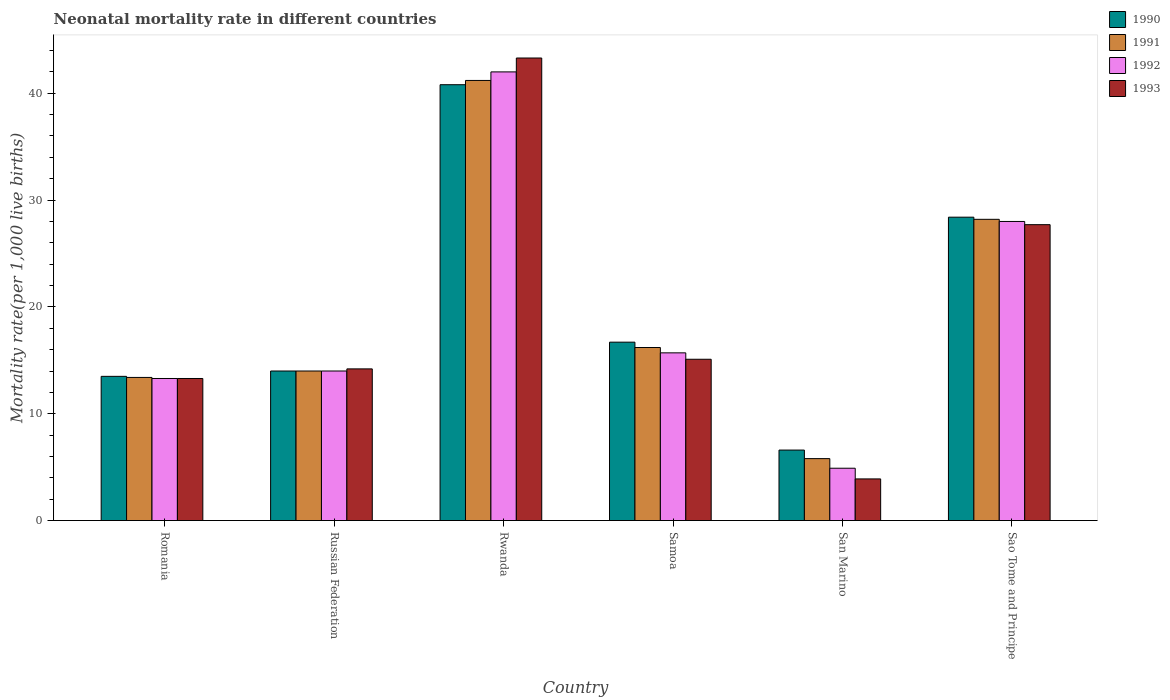Are the number of bars per tick equal to the number of legend labels?
Ensure brevity in your answer.  Yes. Are the number of bars on each tick of the X-axis equal?
Your answer should be compact. Yes. How many bars are there on the 1st tick from the right?
Offer a very short reply. 4. What is the label of the 1st group of bars from the left?
Provide a succinct answer. Romania. In which country was the neonatal mortality rate in 1991 maximum?
Your response must be concise. Rwanda. In which country was the neonatal mortality rate in 1990 minimum?
Your answer should be very brief. San Marino. What is the total neonatal mortality rate in 1990 in the graph?
Provide a short and direct response. 120. What is the difference between the neonatal mortality rate in 1992 in Romania and the neonatal mortality rate in 1990 in Russian Federation?
Provide a short and direct response. -0.7. What is the average neonatal mortality rate in 1993 per country?
Provide a short and direct response. 19.58. What is the difference between the neonatal mortality rate of/in 1993 and neonatal mortality rate of/in 1991 in Sao Tome and Principe?
Your answer should be very brief. -0.5. What is the ratio of the neonatal mortality rate in 1992 in Romania to that in Russian Federation?
Keep it short and to the point. 0.95. What is the difference between the highest and the second highest neonatal mortality rate in 1990?
Your answer should be very brief. 24.1. What is the difference between the highest and the lowest neonatal mortality rate in 1992?
Ensure brevity in your answer.  37.1. In how many countries, is the neonatal mortality rate in 1991 greater than the average neonatal mortality rate in 1991 taken over all countries?
Your response must be concise. 2. Is it the case that in every country, the sum of the neonatal mortality rate in 1990 and neonatal mortality rate in 1993 is greater than the sum of neonatal mortality rate in 1992 and neonatal mortality rate in 1991?
Provide a succinct answer. No. Is it the case that in every country, the sum of the neonatal mortality rate in 1991 and neonatal mortality rate in 1993 is greater than the neonatal mortality rate in 1990?
Provide a succinct answer. Yes. How many bars are there?
Your response must be concise. 24. How many countries are there in the graph?
Make the answer very short. 6. Are the values on the major ticks of Y-axis written in scientific E-notation?
Your answer should be very brief. No. Does the graph contain any zero values?
Your answer should be compact. No. Where does the legend appear in the graph?
Provide a succinct answer. Top right. How many legend labels are there?
Provide a short and direct response. 4. How are the legend labels stacked?
Your response must be concise. Vertical. What is the title of the graph?
Make the answer very short. Neonatal mortality rate in different countries. What is the label or title of the Y-axis?
Offer a terse response. Mortality rate(per 1,0 live births). What is the Mortality rate(per 1,000 live births) of 1990 in Romania?
Your answer should be very brief. 13.5. What is the Mortality rate(per 1,000 live births) in 1991 in Romania?
Offer a terse response. 13.4. What is the Mortality rate(per 1,000 live births) of 1992 in Romania?
Give a very brief answer. 13.3. What is the Mortality rate(per 1,000 live births) of 1993 in Romania?
Provide a short and direct response. 13.3. What is the Mortality rate(per 1,000 live births) in 1990 in Russian Federation?
Ensure brevity in your answer.  14. What is the Mortality rate(per 1,000 live births) of 1991 in Russian Federation?
Give a very brief answer. 14. What is the Mortality rate(per 1,000 live births) of 1990 in Rwanda?
Provide a succinct answer. 40.8. What is the Mortality rate(per 1,000 live births) in 1991 in Rwanda?
Provide a short and direct response. 41.2. What is the Mortality rate(per 1,000 live births) in 1993 in Rwanda?
Make the answer very short. 43.3. What is the Mortality rate(per 1,000 live births) of 1990 in Samoa?
Your response must be concise. 16.7. What is the Mortality rate(per 1,000 live births) of 1993 in Samoa?
Offer a terse response. 15.1. What is the Mortality rate(per 1,000 live births) in 1991 in San Marino?
Your answer should be compact. 5.8. What is the Mortality rate(per 1,000 live births) of 1992 in San Marino?
Make the answer very short. 4.9. What is the Mortality rate(per 1,000 live births) in 1993 in San Marino?
Your response must be concise. 3.9. What is the Mortality rate(per 1,000 live births) of 1990 in Sao Tome and Principe?
Provide a short and direct response. 28.4. What is the Mortality rate(per 1,000 live births) in 1991 in Sao Tome and Principe?
Your answer should be very brief. 28.2. What is the Mortality rate(per 1,000 live births) in 1992 in Sao Tome and Principe?
Your response must be concise. 28. What is the Mortality rate(per 1,000 live births) of 1993 in Sao Tome and Principe?
Your response must be concise. 27.7. Across all countries, what is the maximum Mortality rate(per 1,000 live births) of 1990?
Provide a succinct answer. 40.8. Across all countries, what is the maximum Mortality rate(per 1,000 live births) of 1991?
Give a very brief answer. 41.2. Across all countries, what is the maximum Mortality rate(per 1,000 live births) in 1993?
Your answer should be very brief. 43.3. Across all countries, what is the minimum Mortality rate(per 1,000 live births) in 1990?
Keep it short and to the point. 6.6. Across all countries, what is the minimum Mortality rate(per 1,000 live births) in 1991?
Keep it short and to the point. 5.8. Across all countries, what is the minimum Mortality rate(per 1,000 live births) in 1992?
Offer a very short reply. 4.9. Across all countries, what is the minimum Mortality rate(per 1,000 live births) of 1993?
Provide a short and direct response. 3.9. What is the total Mortality rate(per 1,000 live births) in 1990 in the graph?
Provide a succinct answer. 120. What is the total Mortality rate(per 1,000 live births) of 1991 in the graph?
Ensure brevity in your answer.  118.8. What is the total Mortality rate(per 1,000 live births) of 1992 in the graph?
Offer a terse response. 117.9. What is the total Mortality rate(per 1,000 live births) of 1993 in the graph?
Ensure brevity in your answer.  117.5. What is the difference between the Mortality rate(per 1,000 live births) in 1991 in Romania and that in Russian Federation?
Your answer should be very brief. -0.6. What is the difference between the Mortality rate(per 1,000 live births) in 1992 in Romania and that in Russian Federation?
Your response must be concise. -0.7. What is the difference between the Mortality rate(per 1,000 live births) of 1990 in Romania and that in Rwanda?
Your response must be concise. -27.3. What is the difference between the Mortality rate(per 1,000 live births) in 1991 in Romania and that in Rwanda?
Your answer should be very brief. -27.8. What is the difference between the Mortality rate(per 1,000 live births) in 1992 in Romania and that in Rwanda?
Provide a succinct answer. -28.7. What is the difference between the Mortality rate(per 1,000 live births) of 1992 in Romania and that in Samoa?
Make the answer very short. -2.4. What is the difference between the Mortality rate(per 1,000 live births) in 1993 in Romania and that in Samoa?
Offer a terse response. -1.8. What is the difference between the Mortality rate(per 1,000 live births) in 1992 in Romania and that in San Marino?
Your answer should be very brief. 8.4. What is the difference between the Mortality rate(per 1,000 live births) of 1990 in Romania and that in Sao Tome and Principe?
Your answer should be very brief. -14.9. What is the difference between the Mortality rate(per 1,000 live births) in 1991 in Romania and that in Sao Tome and Principe?
Provide a short and direct response. -14.8. What is the difference between the Mortality rate(per 1,000 live births) in 1992 in Romania and that in Sao Tome and Principe?
Offer a terse response. -14.7. What is the difference between the Mortality rate(per 1,000 live births) in 1993 in Romania and that in Sao Tome and Principe?
Your answer should be very brief. -14.4. What is the difference between the Mortality rate(per 1,000 live births) in 1990 in Russian Federation and that in Rwanda?
Provide a succinct answer. -26.8. What is the difference between the Mortality rate(per 1,000 live births) of 1991 in Russian Federation and that in Rwanda?
Provide a succinct answer. -27.2. What is the difference between the Mortality rate(per 1,000 live births) in 1992 in Russian Federation and that in Rwanda?
Your response must be concise. -28. What is the difference between the Mortality rate(per 1,000 live births) in 1993 in Russian Federation and that in Rwanda?
Your answer should be very brief. -29.1. What is the difference between the Mortality rate(per 1,000 live births) in 1990 in Russian Federation and that in Samoa?
Offer a terse response. -2.7. What is the difference between the Mortality rate(per 1,000 live births) in 1992 in Russian Federation and that in Samoa?
Give a very brief answer. -1.7. What is the difference between the Mortality rate(per 1,000 live births) of 1992 in Russian Federation and that in San Marino?
Provide a short and direct response. 9.1. What is the difference between the Mortality rate(per 1,000 live births) in 1993 in Russian Federation and that in San Marino?
Keep it short and to the point. 10.3. What is the difference between the Mortality rate(per 1,000 live births) of 1990 in Russian Federation and that in Sao Tome and Principe?
Ensure brevity in your answer.  -14.4. What is the difference between the Mortality rate(per 1,000 live births) of 1991 in Russian Federation and that in Sao Tome and Principe?
Your answer should be very brief. -14.2. What is the difference between the Mortality rate(per 1,000 live births) in 1990 in Rwanda and that in Samoa?
Provide a short and direct response. 24.1. What is the difference between the Mortality rate(per 1,000 live births) in 1991 in Rwanda and that in Samoa?
Keep it short and to the point. 25. What is the difference between the Mortality rate(per 1,000 live births) in 1992 in Rwanda and that in Samoa?
Offer a terse response. 26.3. What is the difference between the Mortality rate(per 1,000 live births) of 1993 in Rwanda and that in Samoa?
Keep it short and to the point. 28.2. What is the difference between the Mortality rate(per 1,000 live births) in 1990 in Rwanda and that in San Marino?
Your answer should be very brief. 34.2. What is the difference between the Mortality rate(per 1,000 live births) in 1991 in Rwanda and that in San Marino?
Ensure brevity in your answer.  35.4. What is the difference between the Mortality rate(per 1,000 live births) in 1992 in Rwanda and that in San Marino?
Offer a terse response. 37.1. What is the difference between the Mortality rate(per 1,000 live births) of 1993 in Rwanda and that in San Marino?
Your answer should be compact. 39.4. What is the difference between the Mortality rate(per 1,000 live births) of 1990 in Samoa and that in San Marino?
Provide a succinct answer. 10.1. What is the difference between the Mortality rate(per 1,000 live births) of 1993 in Samoa and that in San Marino?
Keep it short and to the point. 11.2. What is the difference between the Mortality rate(per 1,000 live births) of 1991 in Samoa and that in Sao Tome and Principe?
Offer a terse response. -12. What is the difference between the Mortality rate(per 1,000 live births) of 1992 in Samoa and that in Sao Tome and Principe?
Offer a terse response. -12.3. What is the difference between the Mortality rate(per 1,000 live births) in 1990 in San Marino and that in Sao Tome and Principe?
Offer a very short reply. -21.8. What is the difference between the Mortality rate(per 1,000 live births) of 1991 in San Marino and that in Sao Tome and Principe?
Your answer should be compact. -22.4. What is the difference between the Mortality rate(per 1,000 live births) in 1992 in San Marino and that in Sao Tome and Principe?
Your answer should be very brief. -23.1. What is the difference between the Mortality rate(per 1,000 live births) in 1993 in San Marino and that in Sao Tome and Principe?
Your answer should be very brief. -23.8. What is the difference between the Mortality rate(per 1,000 live births) of 1990 in Romania and the Mortality rate(per 1,000 live births) of 1991 in Russian Federation?
Offer a terse response. -0.5. What is the difference between the Mortality rate(per 1,000 live births) in 1990 in Romania and the Mortality rate(per 1,000 live births) in 1991 in Rwanda?
Your answer should be very brief. -27.7. What is the difference between the Mortality rate(per 1,000 live births) in 1990 in Romania and the Mortality rate(per 1,000 live births) in 1992 in Rwanda?
Give a very brief answer. -28.5. What is the difference between the Mortality rate(per 1,000 live births) in 1990 in Romania and the Mortality rate(per 1,000 live births) in 1993 in Rwanda?
Ensure brevity in your answer.  -29.8. What is the difference between the Mortality rate(per 1,000 live births) of 1991 in Romania and the Mortality rate(per 1,000 live births) of 1992 in Rwanda?
Offer a very short reply. -28.6. What is the difference between the Mortality rate(per 1,000 live births) in 1991 in Romania and the Mortality rate(per 1,000 live births) in 1993 in Rwanda?
Provide a short and direct response. -29.9. What is the difference between the Mortality rate(per 1,000 live births) in 1992 in Romania and the Mortality rate(per 1,000 live births) in 1993 in Rwanda?
Make the answer very short. -30. What is the difference between the Mortality rate(per 1,000 live births) in 1990 in Romania and the Mortality rate(per 1,000 live births) in 1991 in Samoa?
Keep it short and to the point. -2.7. What is the difference between the Mortality rate(per 1,000 live births) in 1990 in Romania and the Mortality rate(per 1,000 live births) in 1992 in Samoa?
Make the answer very short. -2.2. What is the difference between the Mortality rate(per 1,000 live births) in 1991 in Romania and the Mortality rate(per 1,000 live births) in 1993 in Samoa?
Keep it short and to the point. -1.7. What is the difference between the Mortality rate(per 1,000 live births) in 1990 in Romania and the Mortality rate(per 1,000 live births) in 1991 in San Marino?
Give a very brief answer. 7.7. What is the difference between the Mortality rate(per 1,000 live births) of 1990 in Romania and the Mortality rate(per 1,000 live births) of 1993 in San Marino?
Provide a succinct answer. 9.6. What is the difference between the Mortality rate(per 1,000 live births) of 1991 in Romania and the Mortality rate(per 1,000 live births) of 1992 in San Marino?
Offer a terse response. 8.5. What is the difference between the Mortality rate(per 1,000 live births) in 1992 in Romania and the Mortality rate(per 1,000 live births) in 1993 in San Marino?
Offer a terse response. 9.4. What is the difference between the Mortality rate(per 1,000 live births) in 1990 in Romania and the Mortality rate(per 1,000 live births) in 1991 in Sao Tome and Principe?
Provide a succinct answer. -14.7. What is the difference between the Mortality rate(per 1,000 live births) in 1990 in Romania and the Mortality rate(per 1,000 live births) in 1992 in Sao Tome and Principe?
Provide a succinct answer. -14.5. What is the difference between the Mortality rate(per 1,000 live births) in 1991 in Romania and the Mortality rate(per 1,000 live births) in 1992 in Sao Tome and Principe?
Provide a succinct answer. -14.6. What is the difference between the Mortality rate(per 1,000 live births) in 1991 in Romania and the Mortality rate(per 1,000 live births) in 1993 in Sao Tome and Principe?
Make the answer very short. -14.3. What is the difference between the Mortality rate(per 1,000 live births) of 1992 in Romania and the Mortality rate(per 1,000 live births) of 1993 in Sao Tome and Principe?
Make the answer very short. -14.4. What is the difference between the Mortality rate(per 1,000 live births) of 1990 in Russian Federation and the Mortality rate(per 1,000 live births) of 1991 in Rwanda?
Ensure brevity in your answer.  -27.2. What is the difference between the Mortality rate(per 1,000 live births) of 1990 in Russian Federation and the Mortality rate(per 1,000 live births) of 1993 in Rwanda?
Provide a short and direct response. -29.3. What is the difference between the Mortality rate(per 1,000 live births) in 1991 in Russian Federation and the Mortality rate(per 1,000 live births) in 1992 in Rwanda?
Ensure brevity in your answer.  -28. What is the difference between the Mortality rate(per 1,000 live births) in 1991 in Russian Federation and the Mortality rate(per 1,000 live births) in 1993 in Rwanda?
Provide a short and direct response. -29.3. What is the difference between the Mortality rate(per 1,000 live births) of 1992 in Russian Federation and the Mortality rate(per 1,000 live births) of 1993 in Rwanda?
Provide a succinct answer. -29.3. What is the difference between the Mortality rate(per 1,000 live births) in 1990 in Russian Federation and the Mortality rate(per 1,000 live births) in 1991 in Samoa?
Keep it short and to the point. -2.2. What is the difference between the Mortality rate(per 1,000 live births) in 1990 in Russian Federation and the Mortality rate(per 1,000 live births) in 1993 in Samoa?
Your answer should be compact. -1.1. What is the difference between the Mortality rate(per 1,000 live births) of 1991 in Russian Federation and the Mortality rate(per 1,000 live births) of 1992 in Samoa?
Offer a terse response. -1.7. What is the difference between the Mortality rate(per 1,000 live births) in 1991 in Russian Federation and the Mortality rate(per 1,000 live births) in 1993 in Samoa?
Your answer should be compact. -1.1. What is the difference between the Mortality rate(per 1,000 live births) of 1990 in Russian Federation and the Mortality rate(per 1,000 live births) of 1991 in San Marino?
Your answer should be compact. 8.2. What is the difference between the Mortality rate(per 1,000 live births) of 1991 in Russian Federation and the Mortality rate(per 1,000 live births) of 1992 in San Marino?
Give a very brief answer. 9.1. What is the difference between the Mortality rate(per 1,000 live births) in 1991 in Russian Federation and the Mortality rate(per 1,000 live births) in 1993 in San Marino?
Offer a very short reply. 10.1. What is the difference between the Mortality rate(per 1,000 live births) in 1992 in Russian Federation and the Mortality rate(per 1,000 live births) in 1993 in San Marino?
Give a very brief answer. 10.1. What is the difference between the Mortality rate(per 1,000 live births) in 1990 in Russian Federation and the Mortality rate(per 1,000 live births) in 1991 in Sao Tome and Principe?
Your answer should be very brief. -14.2. What is the difference between the Mortality rate(per 1,000 live births) of 1990 in Russian Federation and the Mortality rate(per 1,000 live births) of 1992 in Sao Tome and Principe?
Your response must be concise. -14. What is the difference between the Mortality rate(per 1,000 live births) of 1990 in Russian Federation and the Mortality rate(per 1,000 live births) of 1993 in Sao Tome and Principe?
Your answer should be compact. -13.7. What is the difference between the Mortality rate(per 1,000 live births) of 1991 in Russian Federation and the Mortality rate(per 1,000 live births) of 1992 in Sao Tome and Principe?
Your answer should be very brief. -14. What is the difference between the Mortality rate(per 1,000 live births) in 1991 in Russian Federation and the Mortality rate(per 1,000 live births) in 1993 in Sao Tome and Principe?
Your answer should be very brief. -13.7. What is the difference between the Mortality rate(per 1,000 live births) of 1992 in Russian Federation and the Mortality rate(per 1,000 live births) of 1993 in Sao Tome and Principe?
Give a very brief answer. -13.7. What is the difference between the Mortality rate(per 1,000 live births) of 1990 in Rwanda and the Mortality rate(per 1,000 live births) of 1991 in Samoa?
Your response must be concise. 24.6. What is the difference between the Mortality rate(per 1,000 live births) of 1990 in Rwanda and the Mortality rate(per 1,000 live births) of 1992 in Samoa?
Ensure brevity in your answer.  25.1. What is the difference between the Mortality rate(per 1,000 live births) of 1990 in Rwanda and the Mortality rate(per 1,000 live births) of 1993 in Samoa?
Your answer should be compact. 25.7. What is the difference between the Mortality rate(per 1,000 live births) in 1991 in Rwanda and the Mortality rate(per 1,000 live births) in 1992 in Samoa?
Ensure brevity in your answer.  25.5. What is the difference between the Mortality rate(per 1,000 live births) of 1991 in Rwanda and the Mortality rate(per 1,000 live births) of 1993 in Samoa?
Make the answer very short. 26.1. What is the difference between the Mortality rate(per 1,000 live births) of 1992 in Rwanda and the Mortality rate(per 1,000 live births) of 1993 in Samoa?
Provide a short and direct response. 26.9. What is the difference between the Mortality rate(per 1,000 live births) in 1990 in Rwanda and the Mortality rate(per 1,000 live births) in 1992 in San Marino?
Your answer should be very brief. 35.9. What is the difference between the Mortality rate(per 1,000 live births) of 1990 in Rwanda and the Mortality rate(per 1,000 live births) of 1993 in San Marino?
Your response must be concise. 36.9. What is the difference between the Mortality rate(per 1,000 live births) in 1991 in Rwanda and the Mortality rate(per 1,000 live births) in 1992 in San Marino?
Keep it short and to the point. 36.3. What is the difference between the Mortality rate(per 1,000 live births) in 1991 in Rwanda and the Mortality rate(per 1,000 live births) in 1993 in San Marino?
Ensure brevity in your answer.  37.3. What is the difference between the Mortality rate(per 1,000 live births) of 1992 in Rwanda and the Mortality rate(per 1,000 live births) of 1993 in San Marino?
Provide a succinct answer. 38.1. What is the difference between the Mortality rate(per 1,000 live births) in 1990 in Rwanda and the Mortality rate(per 1,000 live births) in 1993 in Sao Tome and Principe?
Keep it short and to the point. 13.1. What is the difference between the Mortality rate(per 1,000 live births) in 1991 in Rwanda and the Mortality rate(per 1,000 live births) in 1993 in Sao Tome and Principe?
Provide a succinct answer. 13.5. What is the difference between the Mortality rate(per 1,000 live births) in 1992 in Rwanda and the Mortality rate(per 1,000 live births) in 1993 in Sao Tome and Principe?
Your answer should be very brief. 14.3. What is the difference between the Mortality rate(per 1,000 live births) of 1992 in Samoa and the Mortality rate(per 1,000 live births) of 1993 in San Marino?
Your answer should be compact. 11.8. What is the difference between the Mortality rate(per 1,000 live births) in 1990 in Samoa and the Mortality rate(per 1,000 live births) in 1992 in Sao Tome and Principe?
Your answer should be very brief. -11.3. What is the difference between the Mortality rate(per 1,000 live births) of 1991 in Samoa and the Mortality rate(per 1,000 live births) of 1992 in Sao Tome and Principe?
Offer a very short reply. -11.8. What is the difference between the Mortality rate(per 1,000 live births) in 1991 in Samoa and the Mortality rate(per 1,000 live births) in 1993 in Sao Tome and Principe?
Ensure brevity in your answer.  -11.5. What is the difference between the Mortality rate(per 1,000 live births) in 1992 in Samoa and the Mortality rate(per 1,000 live births) in 1993 in Sao Tome and Principe?
Ensure brevity in your answer.  -12. What is the difference between the Mortality rate(per 1,000 live births) in 1990 in San Marino and the Mortality rate(per 1,000 live births) in 1991 in Sao Tome and Principe?
Make the answer very short. -21.6. What is the difference between the Mortality rate(per 1,000 live births) in 1990 in San Marino and the Mortality rate(per 1,000 live births) in 1992 in Sao Tome and Principe?
Your response must be concise. -21.4. What is the difference between the Mortality rate(per 1,000 live births) of 1990 in San Marino and the Mortality rate(per 1,000 live births) of 1993 in Sao Tome and Principe?
Your answer should be very brief. -21.1. What is the difference between the Mortality rate(per 1,000 live births) of 1991 in San Marino and the Mortality rate(per 1,000 live births) of 1992 in Sao Tome and Principe?
Provide a short and direct response. -22.2. What is the difference between the Mortality rate(per 1,000 live births) in 1991 in San Marino and the Mortality rate(per 1,000 live births) in 1993 in Sao Tome and Principe?
Your response must be concise. -21.9. What is the difference between the Mortality rate(per 1,000 live births) of 1992 in San Marino and the Mortality rate(per 1,000 live births) of 1993 in Sao Tome and Principe?
Provide a short and direct response. -22.8. What is the average Mortality rate(per 1,000 live births) in 1991 per country?
Your answer should be compact. 19.8. What is the average Mortality rate(per 1,000 live births) in 1992 per country?
Provide a succinct answer. 19.65. What is the average Mortality rate(per 1,000 live births) in 1993 per country?
Your answer should be very brief. 19.58. What is the difference between the Mortality rate(per 1,000 live births) in 1990 and Mortality rate(per 1,000 live births) in 1991 in Romania?
Your response must be concise. 0.1. What is the difference between the Mortality rate(per 1,000 live births) of 1990 and Mortality rate(per 1,000 live births) of 1992 in Romania?
Your answer should be compact. 0.2. What is the difference between the Mortality rate(per 1,000 live births) in 1990 and Mortality rate(per 1,000 live births) in 1993 in Romania?
Offer a terse response. 0.2. What is the difference between the Mortality rate(per 1,000 live births) in 1992 and Mortality rate(per 1,000 live births) in 1993 in Romania?
Give a very brief answer. 0. What is the difference between the Mortality rate(per 1,000 live births) of 1990 and Mortality rate(per 1,000 live births) of 1991 in Russian Federation?
Your answer should be compact. 0. What is the difference between the Mortality rate(per 1,000 live births) in 1990 and Mortality rate(per 1,000 live births) in 1993 in Russian Federation?
Provide a succinct answer. -0.2. What is the difference between the Mortality rate(per 1,000 live births) in 1991 and Mortality rate(per 1,000 live births) in 1992 in Russian Federation?
Make the answer very short. 0. What is the difference between the Mortality rate(per 1,000 live births) in 1991 and Mortality rate(per 1,000 live births) in 1993 in Russian Federation?
Your answer should be very brief. -0.2. What is the difference between the Mortality rate(per 1,000 live births) of 1990 and Mortality rate(per 1,000 live births) of 1992 in Rwanda?
Offer a terse response. -1.2. What is the difference between the Mortality rate(per 1,000 live births) of 1990 and Mortality rate(per 1,000 live births) of 1993 in Rwanda?
Provide a short and direct response. -2.5. What is the difference between the Mortality rate(per 1,000 live births) of 1992 and Mortality rate(per 1,000 live births) of 1993 in Rwanda?
Make the answer very short. -1.3. What is the difference between the Mortality rate(per 1,000 live births) in 1990 and Mortality rate(per 1,000 live births) in 1991 in Samoa?
Your answer should be compact. 0.5. What is the difference between the Mortality rate(per 1,000 live births) of 1990 and Mortality rate(per 1,000 live births) of 1992 in Samoa?
Your answer should be compact. 1. What is the difference between the Mortality rate(per 1,000 live births) in 1991 and Mortality rate(per 1,000 live births) in 1993 in Samoa?
Provide a short and direct response. 1.1. What is the difference between the Mortality rate(per 1,000 live births) in 1990 and Mortality rate(per 1,000 live births) in 1992 in San Marino?
Offer a terse response. 1.7. What is the difference between the Mortality rate(per 1,000 live births) in 1991 and Mortality rate(per 1,000 live births) in 1993 in San Marino?
Keep it short and to the point. 1.9. What is the difference between the Mortality rate(per 1,000 live births) in 1992 and Mortality rate(per 1,000 live births) in 1993 in San Marino?
Provide a short and direct response. 1. What is the difference between the Mortality rate(per 1,000 live births) of 1990 and Mortality rate(per 1,000 live births) of 1991 in Sao Tome and Principe?
Your answer should be compact. 0.2. What is the difference between the Mortality rate(per 1,000 live births) of 1990 and Mortality rate(per 1,000 live births) of 1992 in Sao Tome and Principe?
Offer a terse response. 0.4. What is the difference between the Mortality rate(per 1,000 live births) in 1991 and Mortality rate(per 1,000 live births) in 1992 in Sao Tome and Principe?
Keep it short and to the point. 0.2. What is the difference between the Mortality rate(per 1,000 live births) of 1991 and Mortality rate(per 1,000 live births) of 1993 in Sao Tome and Principe?
Your answer should be very brief. 0.5. What is the difference between the Mortality rate(per 1,000 live births) of 1992 and Mortality rate(per 1,000 live births) of 1993 in Sao Tome and Principe?
Ensure brevity in your answer.  0.3. What is the ratio of the Mortality rate(per 1,000 live births) of 1990 in Romania to that in Russian Federation?
Give a very brief answer. 0.96. What is the ratio of the Mortality rate(per 1,000 live births) of 1991 in Romania to that in Russian Federation?
Your answer should be very brief. 0.96. What is the ratio of the Mortality rate(per 1,000 live births) of 1992 in Romania to that in Russian Federation?
Offer a terse response. 0.95. What is the ratio of the Mortality rate(per 1,000 live births) in 1993 in Romania to that in Russian Federation?
Make the answer very short. 0.94. What is the ratio of the Mortality rate(per 1,000 live births) of 1990 in Romania to that in Rwanda?
Ensure brevity in your answer.  0.33. What is the ratio of the Mortality rate(per 1,000 live births) of 1991 in Romania to that in Rwanda?
Make the answer very short. 0.33. What is the ratio of the Mortality rate(per 1,000 live births) in 1992 in Romania to that in Rwanda?
Provide a succinct answer. 0.32. What is the ratio of the Mortality rate(per 1,000 live births) of 1993 in Romania to that in Rwanda?
Keep it short and to the point. 0.31. What is the ratio of the Mortality rate(per 1,000 live births) in 1990 in Romania to that in Samoa?
Offer a very short reply. 0.81. What is the ratio of the Mortality rate(per 1,000 live births) of 1991 in Romania to that in Samoa?
Offer a terse response. 0.83. What is the ratio of the Mortality rate(per 1,000 live births) in 1992 in Romania to that in Samoa?
Provide a succinct answer. 0.85. What is the ratio of the Mortality rate(per 1,000 live births) in 1993 in Romania to that in Samoa?
Your answer should be compact. 0.88. What is the ratio of the Mortality rate(per 1,000 live births) in 1990 in Romania to that in San Marino?
Your response must be concise. 2.05. What is the ratio of the Mortality rate(per 1,000 live births) of 1991 in Romania to that in San Marino?
Your response must be concise. 2.31. What is the ratio of the Mortality rate(per 1,000 live births) of 1992 in Romania to that in San Marino?
Your response must be concise. 2.71. What is the ratio of the Mortality rate(per 1,000 live births) in 1993 in Romania to that in San Marino?
Ensure brevity in your answer.  3.41. What is the ratio of the Mortality rate(per 1,000 live births) of 1990 in Romania to that in Sao Tome and Principe?
Your response must be concise. 0.48. What is the ratio of the Mortality rate(per 1,000 live births) in 1991 in Romania to that in Sao Tome and Principe?
Give a very brief answer. 0.48. What is the ratio of the Mortality rate(per 1,000 live births) in 1992 in Romania to that in Sao Tome and Principe?
Ensure brevity in your answer.  0.47. What is the ratio of the Mortality rate(per 1,000 live births) of 1993 in Romania to that in Sao Tome and Principe?
Your answer should be compact. 0.48. What is the ratio of the Mortality rate(per 1,000 live births) in 1990 in Russian Federation to that in Rwanda?
Your response must be concise. 0.34. What is the ratio of the Mortality rate(per 1,000 live births) of 1991 in Russian Federation to that in Rwanda?
Make the answer very short. 0.34. What is the ratio of the Mortality rate(per 1,000 live births) in 1992 in Russian Federation to that in Rwanda?
Make the answer very short. 0.33. What is the ratio of the Mortality rate(per 1,000 live births) in 1993 in Russian Federation to that in Rwanda?
Keep it short and to the point. 0.33. What is the ratio of the Mortality rate(per 1,000 live births) in 1990 in Russian Federation to that in Samoa?
Your response must be concise. 0.84. What is the ratio of the Mortality rate(per 1,000 live births) in 1991 in Russian Federation to that in Samoa?
Provide a short and direct response. 0.86. What is the ratio of the Mortality rate(per 1,000 live births) of 1992 in Russian Federation to that in Samoa?
Your answer should be compact. 0.89. What is the ratio of the Mortality rate(per 1,000 live births) of 1993 in Russian Federation to that in Samoa?
Your answer should be very brief. 0.94. What is the ratio of the Mortality rate(per 1,000 live births) in 1990 in Russian Federation to that in San Marino?
Give a very brief answer. 2.12. What is the ratio of the Mortality rate(per 1,000 live births) in 1991 in Russian Federation to that in San Marino?
Ensure brevity in your answer.  2.41. What is the ratio of the Mortality rate(per 1,000 live births) of 1992 in Russian Federation to that in San Marino?
Your response must be concise. 2.86. What is the ratio of the Mortality rate(per 1,000 live births) of 1993 in Russian Federation to that in San Marino?
Provide a short and direct response. 3.64. What is the ratio of the Mortality rate(per 1,000 live births) of 1990 in Russian Federation to that in Sao Tome and Principe?
Offer a terse response. 0.49. What is the ratio of the Mortality rate(per 1,000 live births) of 1991 in Russian Federation to that in Sao Tome and Principe?
Your answer should be very brief. 0.5. What is the ratio of the Mortality rate(per 1,000 live births) in 1993 in Russian Federation to that in Sao Tome and Principe?
Your answer should be very brief. 0.51. What is the ratio of the Mortality rate(per 1,000 live births) of 1990 in Rwanda to that in Samoa?
Your answer should be very brief. 2.44. What is the ratio of the Mortality rate(per 1,000 live births) in 1991 in Rwanda to that in Samoa?
Your answer should be very brief. 2.54. What is the ratio of the Mortality rate(per 1,000 live births) of 1992 in Rwanda to that in Samoa?
Your answer should be very brief. 2.68. What is the ratio of the Mortality rate(per 1,000 live births) in 1993 in Rwanda to that in Samoa?
Your answer should be compact. 2.87. What is the ratio of the Mortality rate(per 1,000 live births) of 1990 in Rwanda to that in San Marino?
Give a very brief answer. 6.18. What is the ratio of the Mortality rate(per 1,000 live births) of 1991 in Rwanda to that in San Marino?
Provide a succinct answer. 7.1. What is the ratio of the Mortality rate(per 1,000 live births) of 1992 in Rwanda to that in San Marino?
Provide a succinct answer. 8.57. What is the ratio of the Mortality rate(per 1,000 live births) of 1993 in Rwanda to that in San Marino?
Ensure brevity in your answer.  11.1. What is the ratio of the Mortality rate(per 1,000 live births) in 1990 in Rwanda to that in Sao Tome and Principe?
Provide a succinct answer. 1.44. What is the ratio of the Mortality rate(per 1,000 live births) of 1991 in Rwanda to that in Sao Tome and Principe?
Offer a very short reply. 1.46. What is the ratio of the Mortality rate(per 1,000 live births) in 1993 in Rwanda to that in Sao Tome and Principe?
Your response must be concise. 1.56. What is the ratio of the Mortality rate(per 1,000 live births) of 1990 in Samoa to that in San Marino?
Your response must be concise. 2.53. What is the ratio of the Mortality rate(per 1,000 live births) of 1991 in Samoa to that in San Marino?
Ensure brevity in your answer.  2.79. What is the ratio of the Mortality rate(per 1,000 live births) of 1992 in Samoa to that in San Marino?
Ensure brevity in your answer.  3.2. What is the ratio of the Mortality rate(per 1,000 live births) of 1993 in Samoa to that in San Marino?
Give a very brief answer. 3.87. What is the ratio of the Mortality rate(per 1,000 live births) of 1990 in Samoa to that in Sao Tome and Principe?
Ensure brevity in your answer.  0.59. What is the ratio of the Mortality rate(per 1,000 live births) of 1991 in Samoa to that in Sao Tome and Principe?
Provide a short and direct response. 0.57. What is the ratio of the Mortality rate(per 1,000 live births) in 1992 in Samoa to that in Sao Tome and Principe?
Offer a terse response. 0.56. What is the ratio of the Mortality rate(per 1,000 live births) of 1993 in Samoa to that in Sao Tome and Principe?
Offer a very short reply. 0.55. What is the ratio of the Mortality rate(per 1,000 live births) in 1990 in San Marino to that in Sao Tome and Principe?
Offer a very short reply. 0.23. What is the ratio of the Mortality rate(per 1,000 live births) of 1991 in San Marino to that in Sao Tome and Principe?
Keep it short and to the point. 0.21. What is the ratio of the Mortality rate(per 1,000 live births) in 1992 in San Marino to that in Sao Tome and Principe?
Your answer should be very brief. 0.17. What is the ratio of the Mortality rate(per 1,000 live births) in 1993 in San Marino to that in Sao Tome and Principe?
Offer a very short reply. 0.14. What is the difference between the highest and the second highest Mortality rate(per 1,000 live births) in 1990?
Ensure brevity in your answer.  12.4. What is the difference between the highest and the lowest Mortality rate(per 1,000 live births) in 1990?
Your answer should be very brief. 34.2. What is the difference between the highest and the lowest Mortality rate(per 1,000 live births) in 1991?
Provide a succinct answer. 35.4. What is the difference between the highest and the lowest Mortality rate(per 1,000 live births) in 1992?
Make the answer very short. 37.1. What is the difference between the highest and the lowest Mortality rate(per 1,000 live births) in 1993?
Provide a short and direct response. 39.4. 